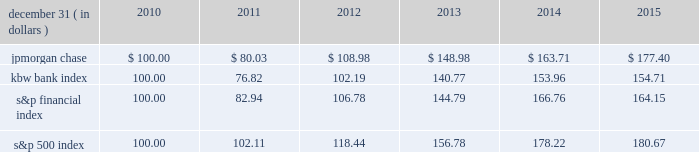Jpmorgan chase & co./2015 annual report 67 five-year stock performance the table and graph compare the five-year cumulative total return for jpmorgan chase & co .
( 201cjpmorgan chase 201d or the 201cfirm 201d ) common stock with the cumulative return of the s&p 500 index , the kbw bank index and the s&p financial index .
The s&p 500 index is a commonly referenced united states of america ( 201cu.s . 201d ) equity benchmark consisting of leading companies from different economic sectors .
The kbw bank index seeks to reflect the performance of banks and thrifts that are publicly traded in the u.s .
And is composed of 24 leading national money center and regional banks and thrifts .
The s&p financial index is an index of 87 financial companies , all of which are components of the s&p 500 .
The firm is a component of all three industry indices .
The table and graph assume simultaneous investments of $ 100 on december 31 , 2010 , in jpmorgan chase common stock and in each of the above indices .
The comparison assumes that all dividends are reinvested .
December 31 , ( in dollars ) 2010 2011 2012 2013 2014 2015 .
December 31 , ( in dollars ) .
Did jpmorgan chase outperform the s&p financial index? 
Computations: (177.40 > 164.15)
Answer: yes. 